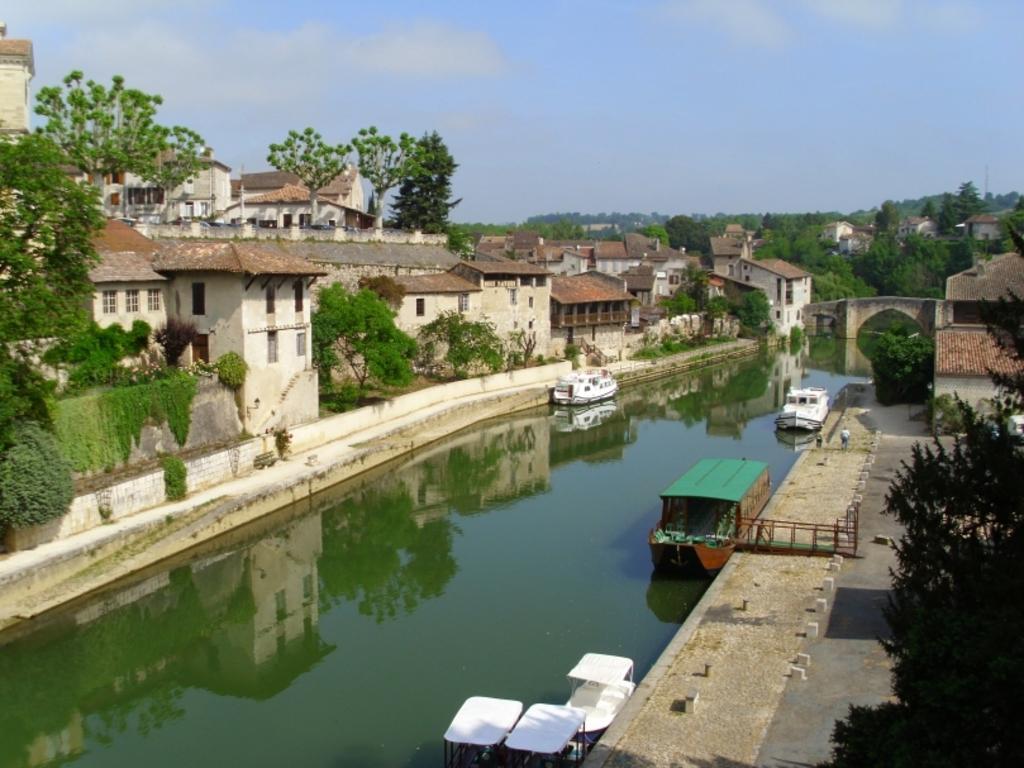In one or two sentences, can you explain what this image depicts? In this image there is the sky towards the top of the image, there are clouds in the sky, there are houses towards the left of the image, there are trees, there are houses towards the right of the image, there is a wall, there is water towards the bottom of the image, there are boats, there is a tree towards the right of the image, there is a man standing, there is ground towards the bottom of the image, there are objects on the ground. 